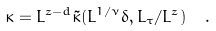<formula> <loc_0><loc_0><loc_500><loc_500>\kappa = L ^ { z - d } \tilde { \kappa } ( L ^ { 1 / \nu } \delta , L _ { \tau } / L ^ { z } ) \ \ .</formula> 